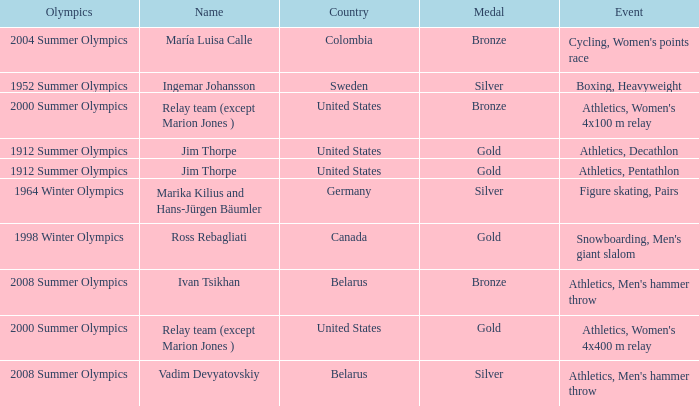What is the event in the 2000 summer olympics with a bronze medal? Athletics, Women's 4x100 m relay. 